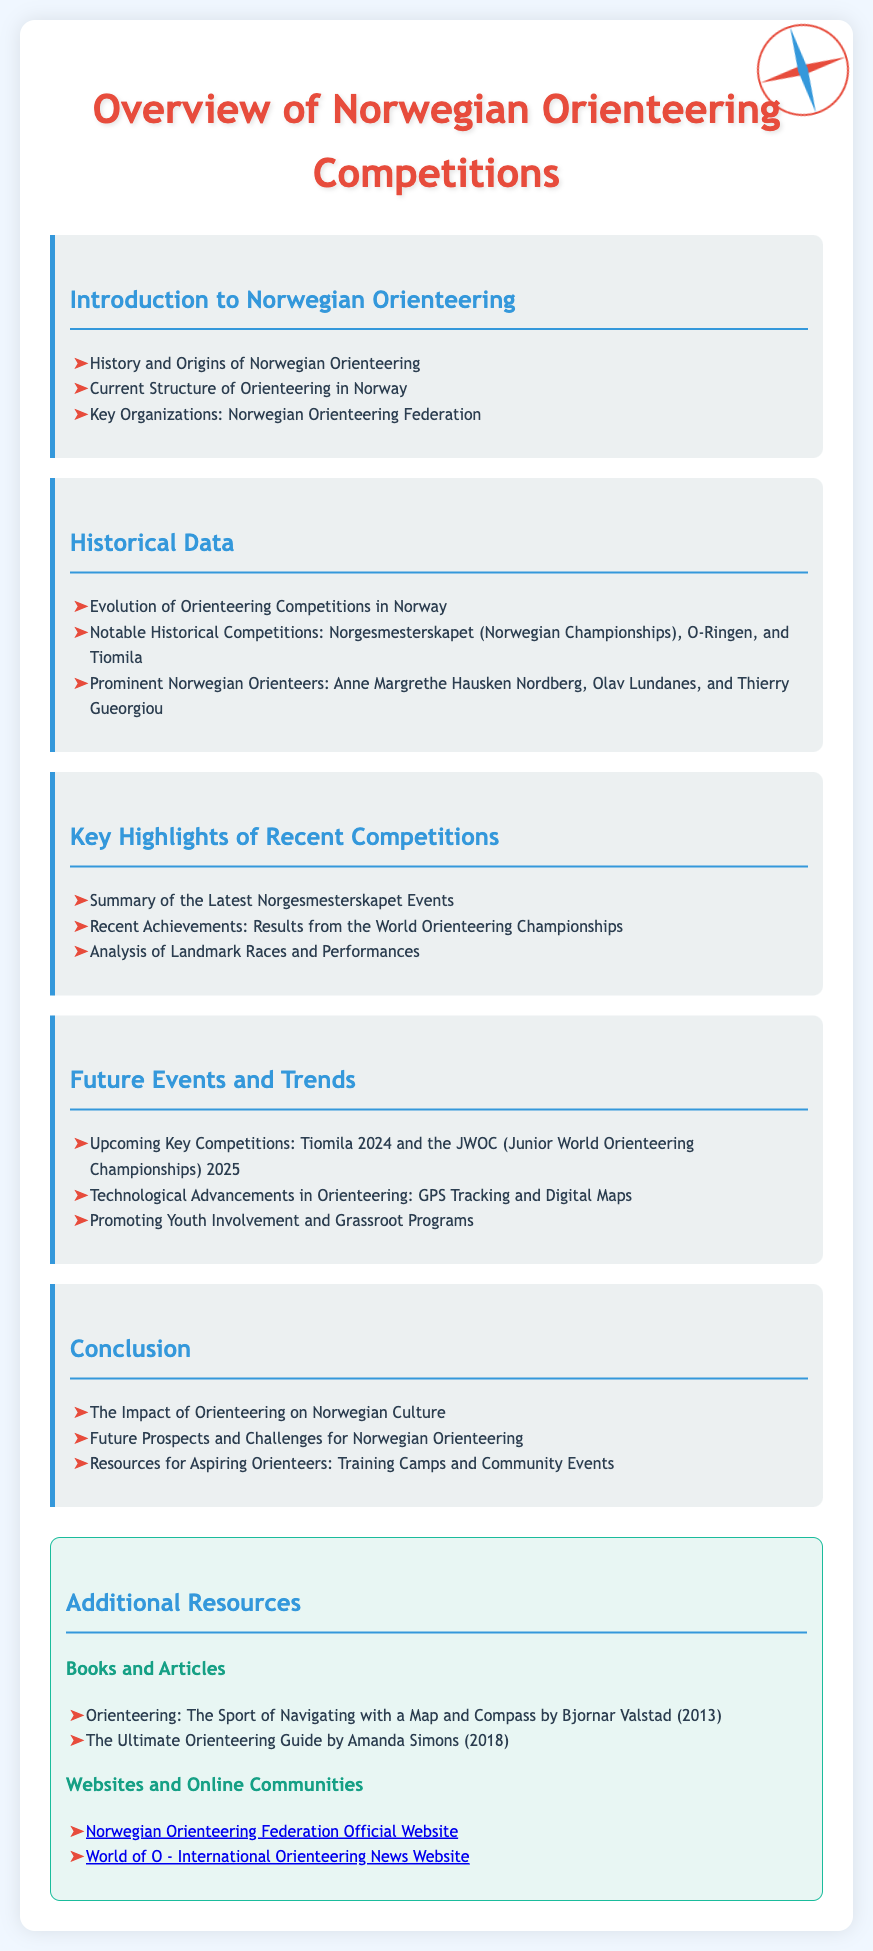what is the title of the syllabus? The title is provided in the main heading of the document, which is "Overview of Norwegian Orienteering Competitions."
Answer: Overview of Norwegian Orienteering Competitions who is a prominent Norwegian orienteer mentioned in the syllabus? The syllabus lists notable individuals in the sport, one of whom is Anne Margrethe Hausken Nordberg.
Answer: Anne Margrethe Hausken Nordberg how many upcoming key competitions are mentioned in the document? The syllabus states there are two upcoming key competitions, which are Tiomila 2024 and JWOC 2025.
Answer: 2 what is the focus of the section titled "Key Highlights of Recent Competitions"? This section summarizes achievements and analysis related to recent orienteering events and performances.
Answer: Recent achievements and analysis what technological advancement in orienteering is highlighted in the syllabus? The syllabus discusses GPS Tracking and Digital Maps as advancements in the sport.
Answer: GPS Tracking and Digital Maps what is one resource type listed under Additional Resources? The document specifies "Books and Articles" as a type of resource for aspiring orienteers.
Answer: Books and Articles how is orienteering's impact on culture described in the syllabus? The impact is described in the conclusion section, highlighting its significance to Norwegian culture.
Answer: The Impact of Orienteering on Norwegian Culture what does the "Historical Data" section discuss? This section covers the evolution of orienteering competitions in Norway and notable events.
Answer: Evolution of Orienteering Competitions in Norway 